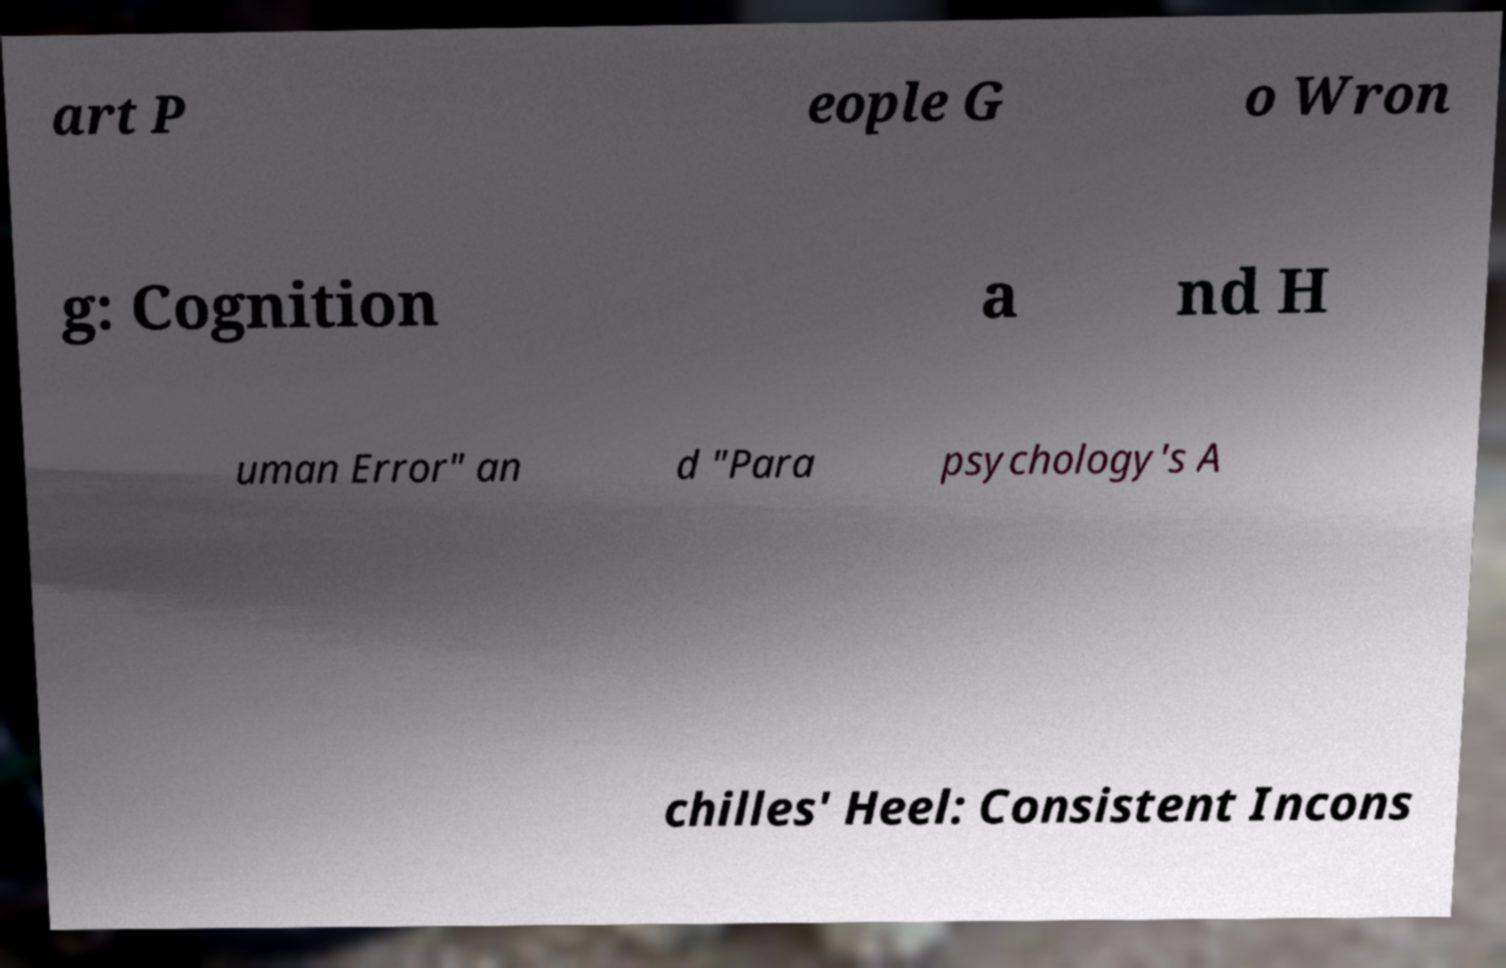I need the written content from this picture converted into text. Can you do that? art P eople G o Wron g: Cognition a nd H uman Error" an d "Para psychology's A chilles' Heel: Consistent Incons 